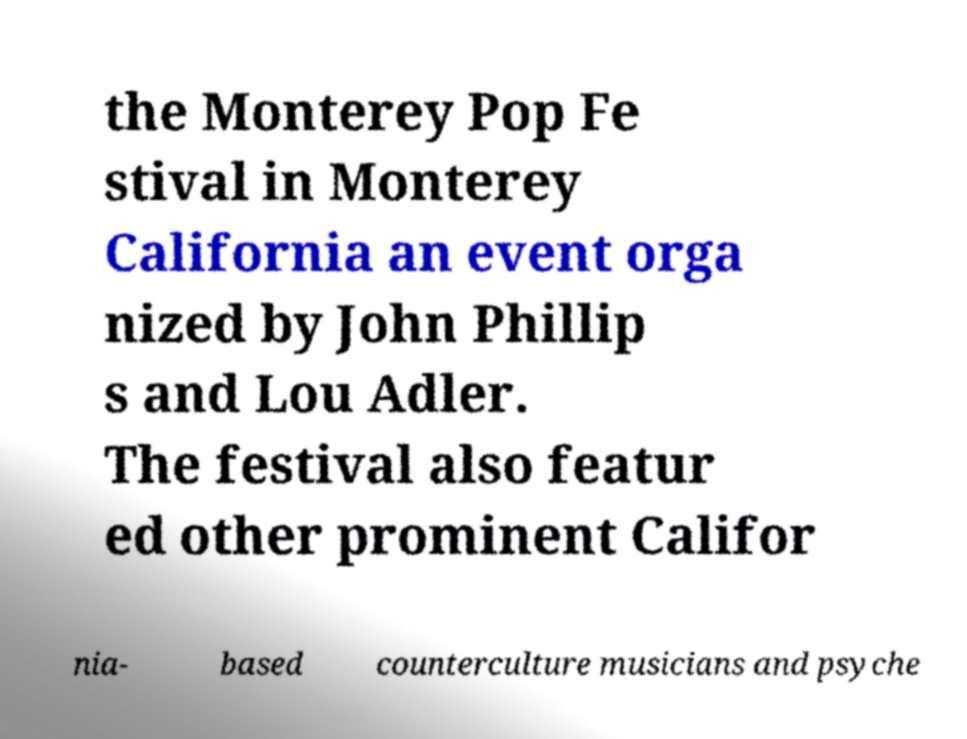What messages or text are displayed in this image? I need them in a readable, typed format. the Monterey Pop Fe stival in Monterey California an event orga nized by John Phillip s and Lou Adler. The festival also featur ed other prominent Califor nia- based counterculture musicians and psyche 